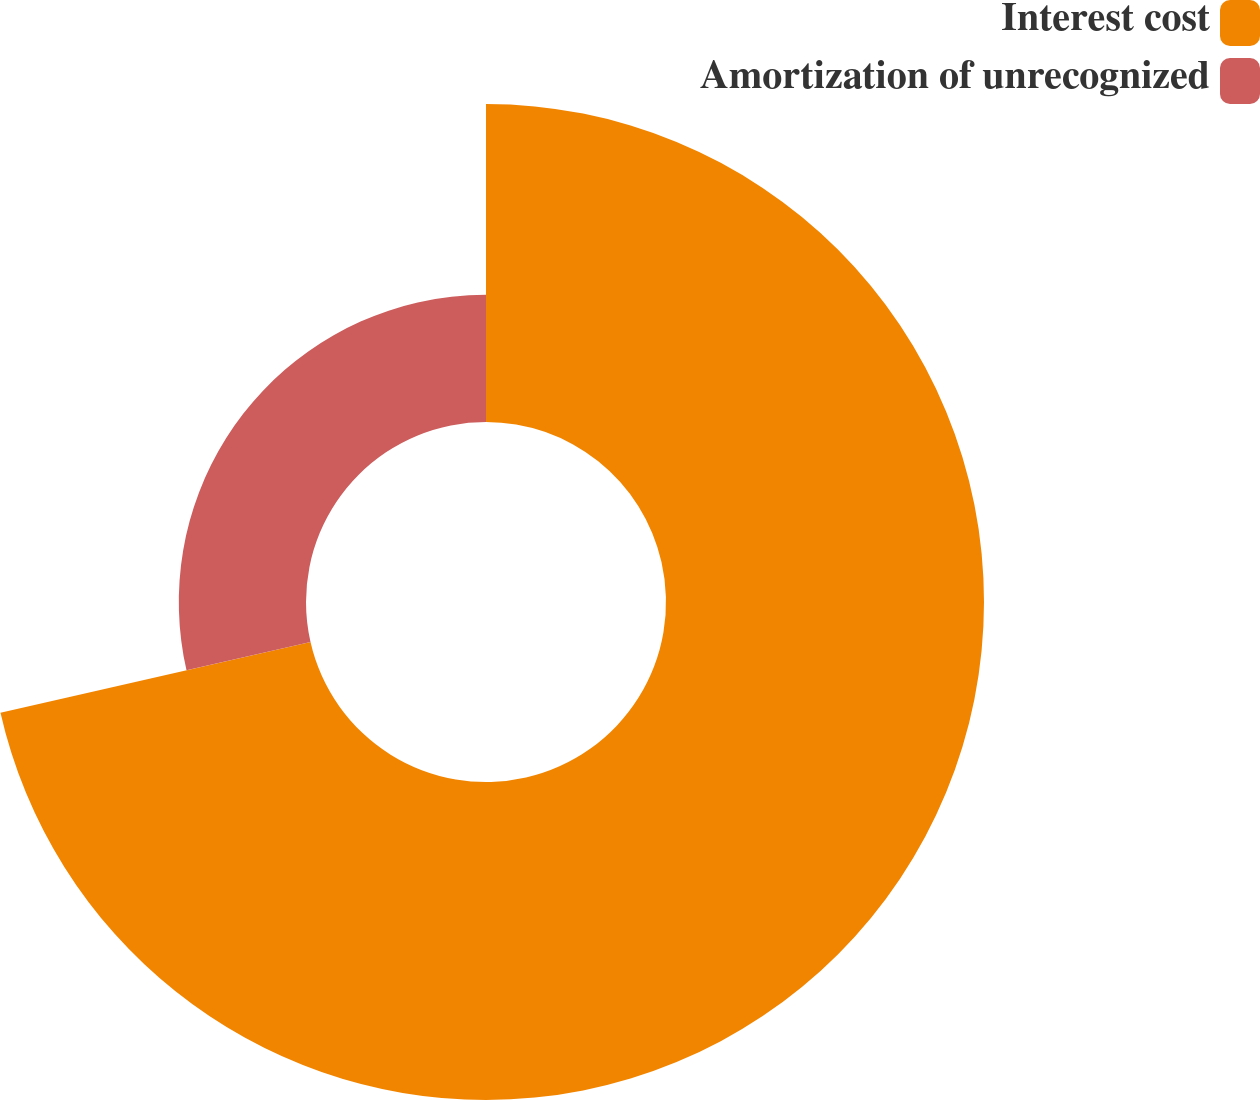Convert chart to OTSL. <chart><loc_0><loc_0><loc_500><loc_500><pie_chart><fcel>Interest cost<fcel>Amortization of unrecognized<nl><fcel>71.43%<fcel>28.57%<nl></chart> 